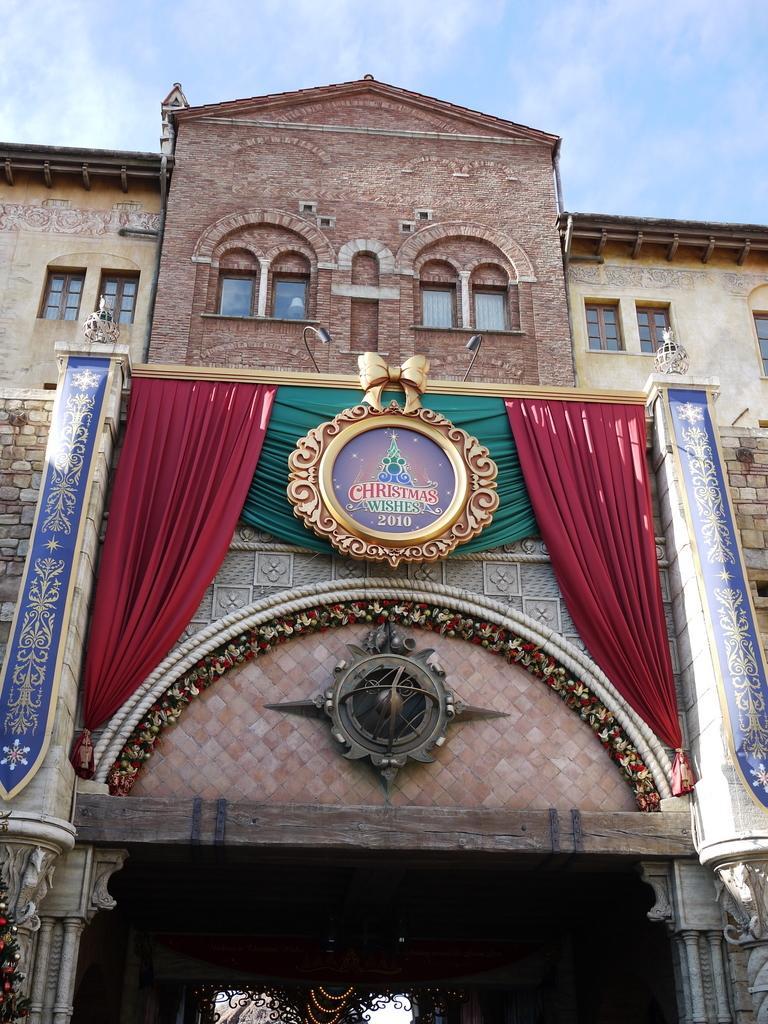How would you summarize this image in a sentence or two? Building with windows. Sky is cloudy. Here we can see curtains and board. 